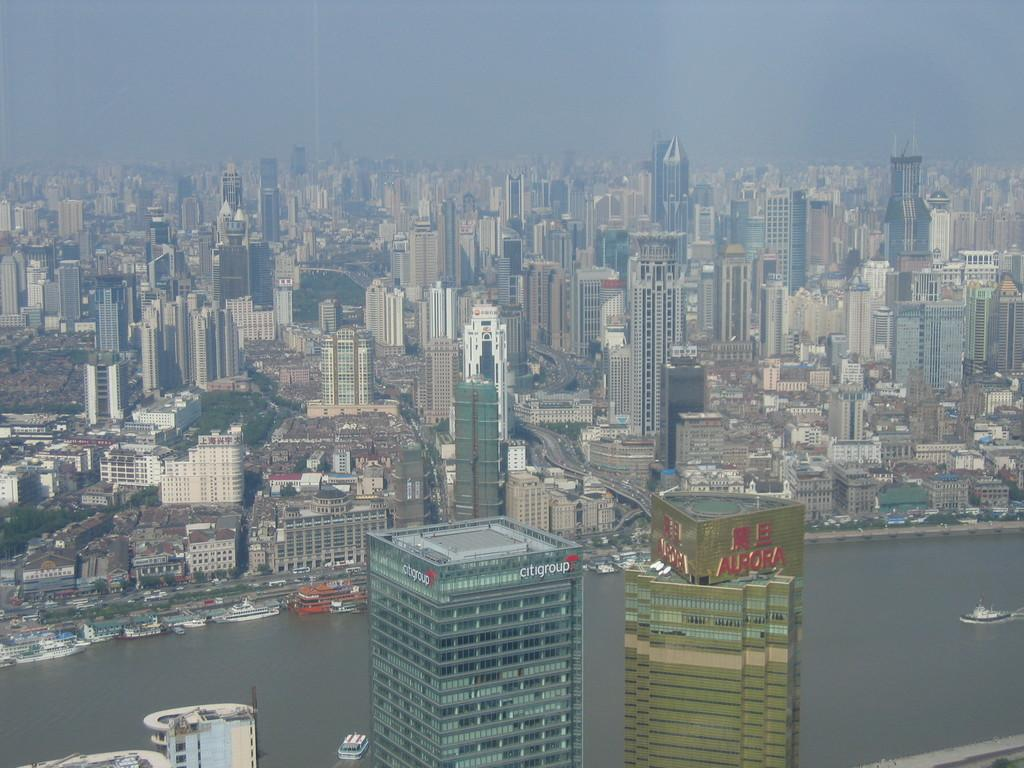What perspective is used to capture the image? The image is taken from a top view. What type of structures can be seen in the image? There are buildings in the city visible in the image. What natural element is present in the image? There is water visible in the image. What types of watercraft are present in the water? Boats and ships are visible in the image. What part of the environment is visible in the image? The sky is visible in the image. How many houses are visible on the ground in the image? There are no houses visible on the ground in the image, as it is taken from a top view and focuses on buildings, water, boats, ships, and the sky. What type of wheel can be seen on the boats in the image? There are no wheels visible on the boats in the image, as boats typically do not have wheels. 